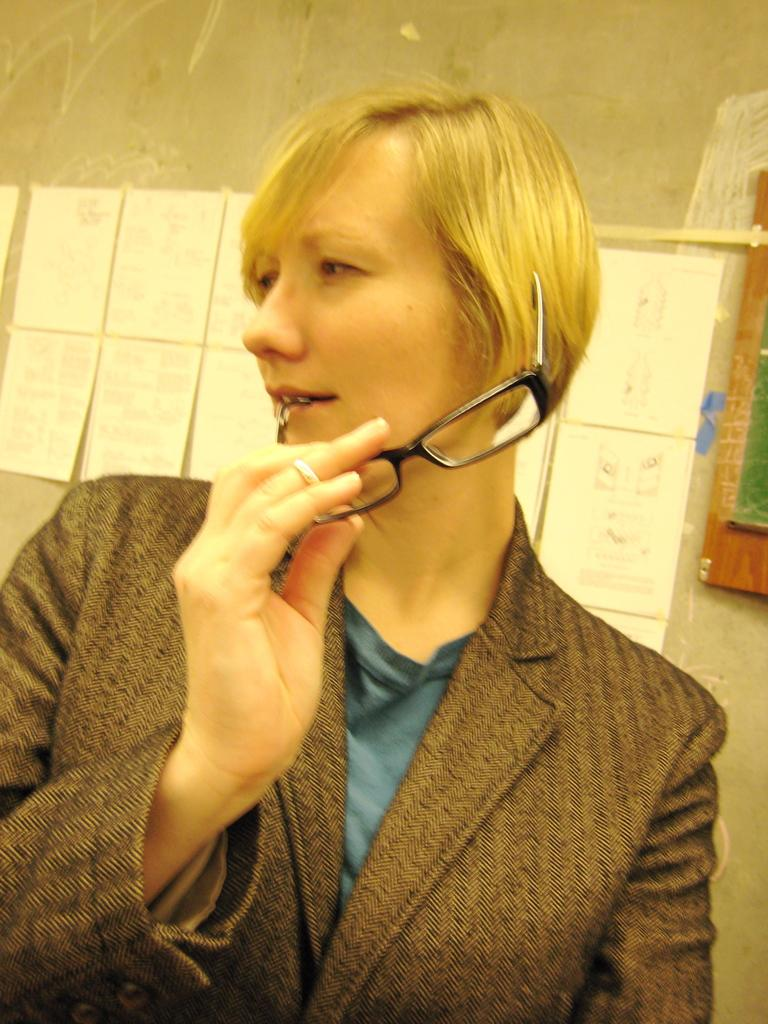What is the main subject of the image? There is a woman in the image. What is the woman holding in her hand? The woman is holding a spectacle in her hand. What is the woman doing with the spectacle? The woman is holding a spectacle in her mouth. What else can be seen in the image besides the woman and the spectacle? There are papers in the image. What is on the wall in the image? There is a frame on the wall in the image. What type of airplane is visible in the image? There is no airplane present in the image. What insect can be seen crawling on the frame on the wall? There are no insects visible in the image; only the woman, spectacle, papers, and frame on the wall are present. 